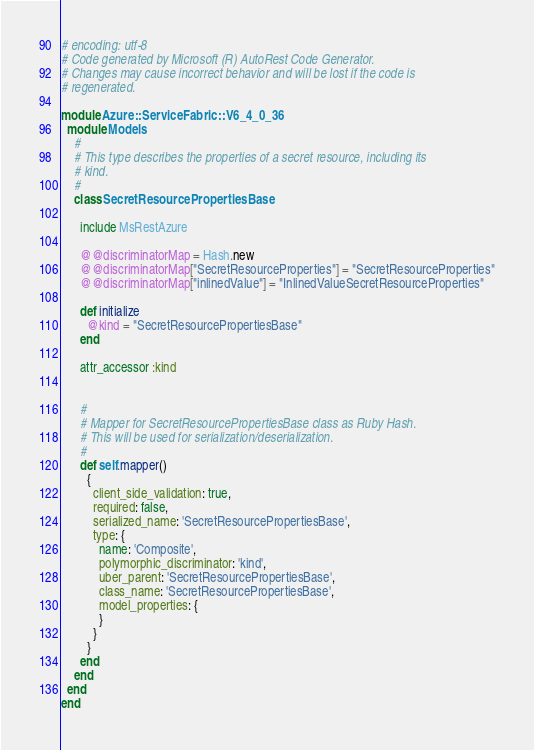Convert code to text. <code><loc_0><loc_0><loc_500><loc_500><_Ruby_># encoding: utf-8
# Code generated by Microsoft (R) AutoRest Code Generator.
# Changes may cause incorrect behavior and will be lost if the code is
# regenerated.

module Azure::ServiceFabric::V6_4_0_36
  module Models
    #
    # This type describes the properties of a secret resource, including its
    # kind.
    #
    class SecretResourcePropertiesBase

      include MsRestAzure

      @@discriminatorMap = Hash.new
      @@discriminatorMap["SecretResourceProperties"] = "SecretResourceProperties"
      @@discriminatorMap["inlinedValue"] = "InlinedValueSecretResourceProperties"

      def initialize
        @kind = "SecretResourcePropertiesBase"
      end

      attr_accessor :kind


      #
      # Mapper for SecretResourcePropertiesBase class as Ruby Hash.
      # This will be used for serialization/deserialization.
      #
      def self.mapper()
        {
          client_side_validation: true,
          required: false,
          serialized_name: 'SecretResourcePropertiesBase',
          type: {
            name: 'Composite',
            polymorphic_discriminator: 'kind',
            uber_parent: 'SecretResourcePropertiesBase',
            class_name: 'SecretResourcePropertiesBase',
            model_properties: {
            }
          }
        }
      end
    end
  end
end
</code> 